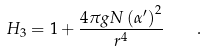<formula> <loc_0><loc_0><loc_500><loc_500>H _ { 3 } = 1 + { \frac { 4 \pi g N \left ( \alpha ^ { \prime } \right ) ^ { 2 } } { r ^ { 4 } } } \quad .</formula> 